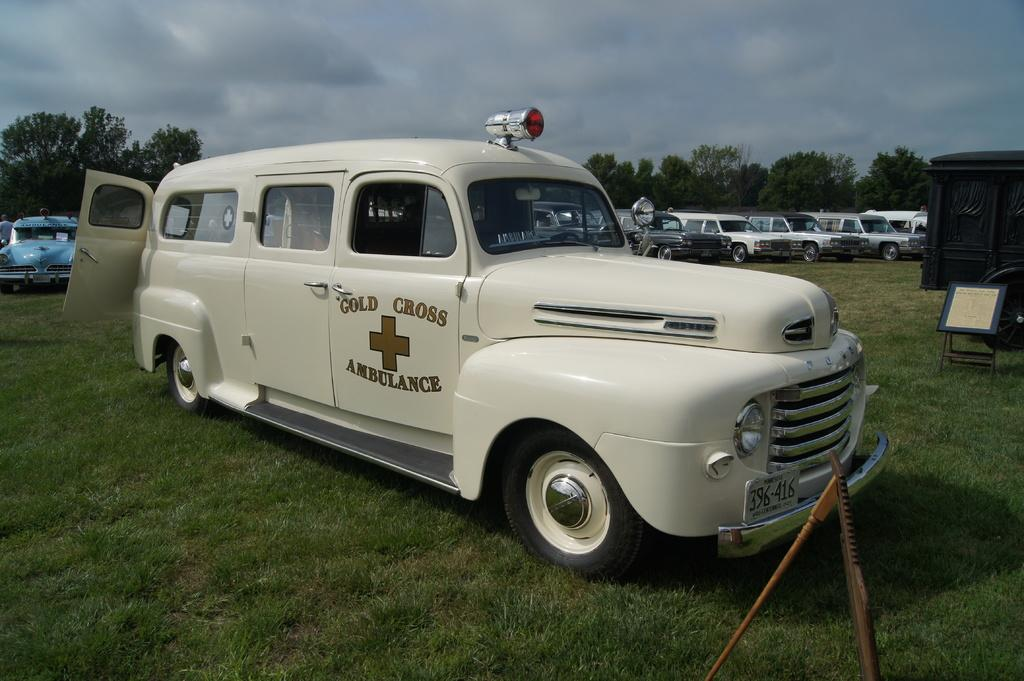<image>
Give a short and clear explanation of the subsequent image. An antique Gold Cross ambulance sits in a grass field. 